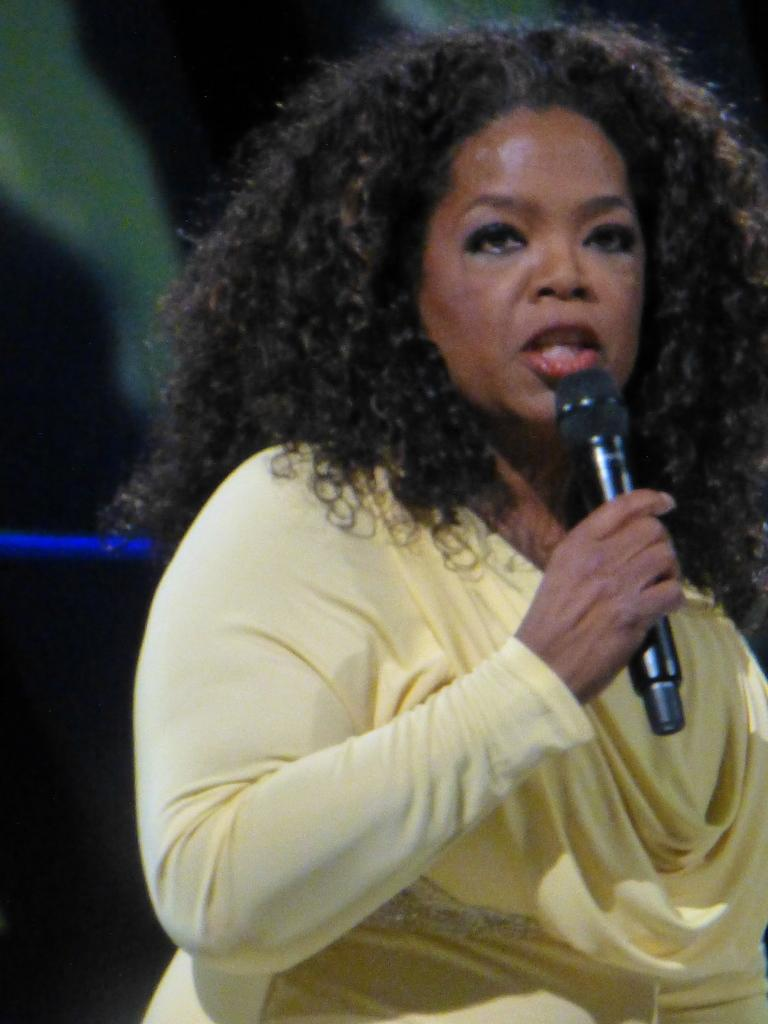Who is the main subject in the image? There is a woman in the image. What is the woman wearing? The woman is wearing a yellow dress. What is the woman holding in her hand? The woman is holding a microphone in her hand. What type of invention can be seen in the woman's hand in the image? There is no invention visible in the woman's hand in the image; she is holding a microphone. Can you see any horns on the woman's head in the image? There are no horns visible on the woman's head in the image. 